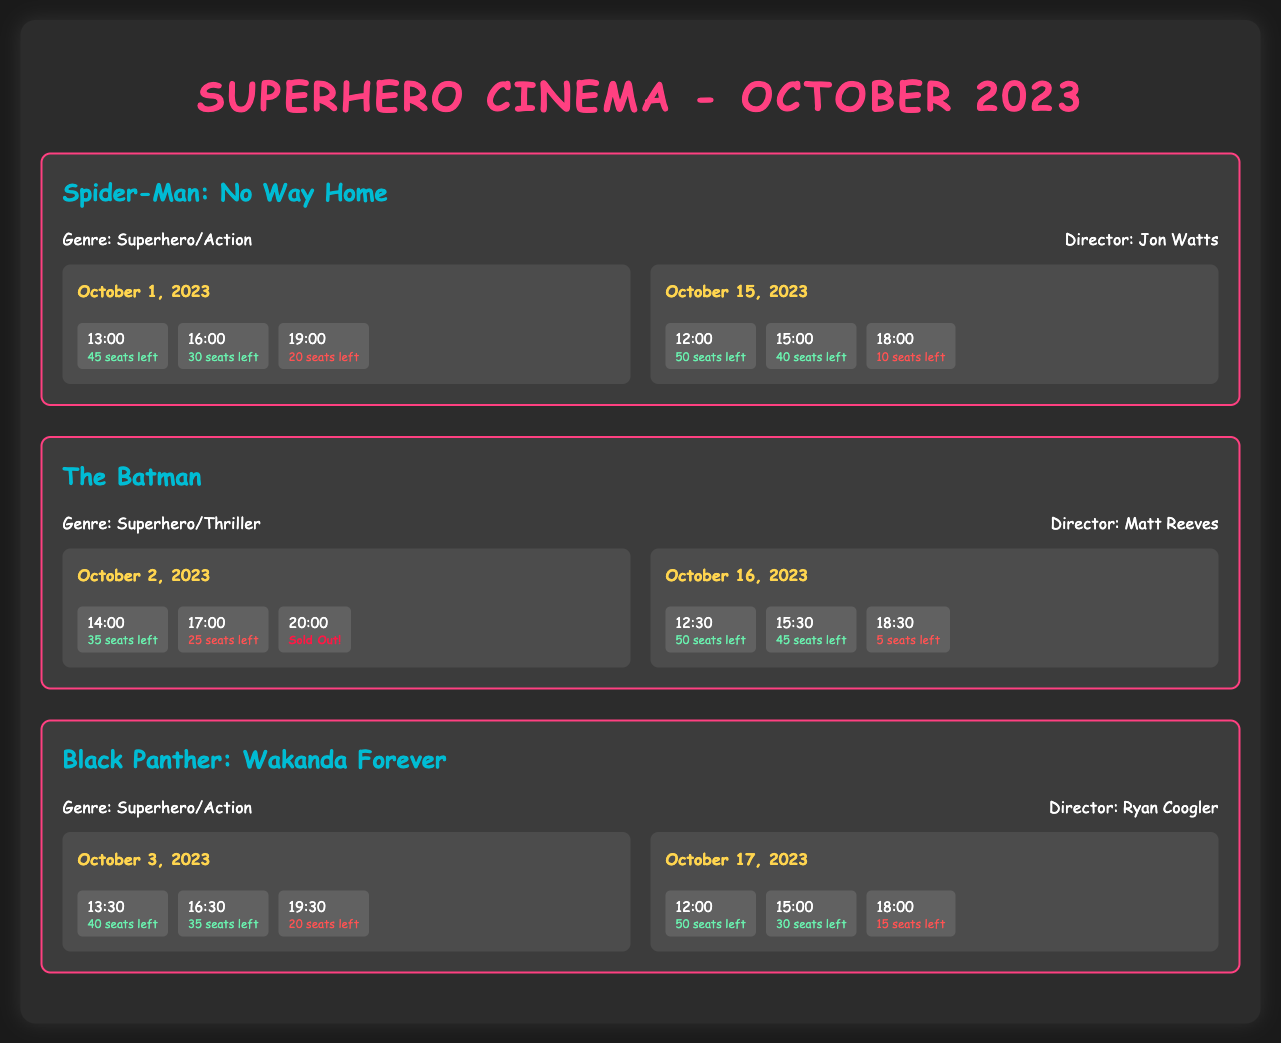What is the genre of "Spider-Man: No Way Home"? The genre is listed in the document and is categorized as Superhero/Action.
Answer: Superhero/Action How many seats are left for the 19:00 showing of "Spider-Man: No Way Home" on October 1, 2023? This information is found in the screening details for the specific date and time.
Answer: 20 seats left What is the name of the director for "The Batman"? The director's name is mentioned in the movie information section for "The Batman."
Answer: Matt Reeves On which date is "Black Panther: Wakanda Forever" screening that has only 15 seats left? The date can be found in the screening details where the available seats are specified.
Answer: October 17, 2023 What is the total number of screenings for "The Batman"? Count the number of screening sections listed for "The Batman" to determine this.
Answer: 2 Screenings Which movie has a screening that is sold out on October 2, 2023? The sold-out screening is identified in the document where it shows that the screening for "The Batman" at 20:00 is sold out.
Answer: The Batman When is the earliest showing for "Black Panther: Wakanda Forever"? The earliest showing time indicates when the movie can first be watched on a specified date.
Answer: 13:30 How many seats are available for the 15:00 showing of "Spider-Man: No Way Home" on October 15, 2023? This is a specific inquiry about seat availability at a certain time for a particular date.
Answer: 40 seats left 